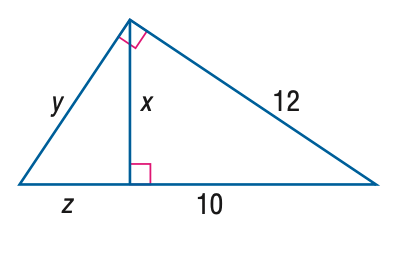Question: Find z.
Choices:
A. \frac { 2 } { 5 } \sqrt { 11 }
B. \frac { 4 } { 5 } \sqrt { 11 }
C. \frac { 22 } { 5 }
D. \frac { 44 } { 5 }
Answer with the letter. Answer: C Question: Find y.
Choices:
A. \frac { 6 } { 5 }
B. \frac { 12 } { 5 }
C. \frac { 6 } { 5 } \sqrt { 11 }
D. \frac { 12 } { 5 } \sqrt { 11 }
Answer with the letter. Answer: D 